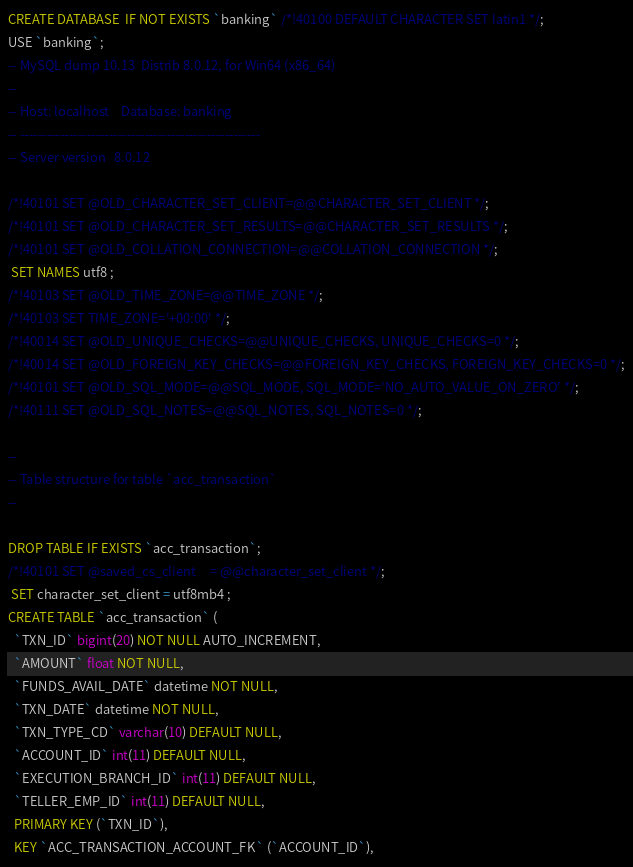Convert code to text. <code><loc_0><loc_0><loc_500><loc_500><_SQL_>CREATE DATABASE  IF NOT EXISTS `banking` /*!40100 DEFAULT CHARACTER SET latin1 */;
USE `banking`;
-- MySQL dump 10.13  Distrib 8.0.12, for Win64 (x86_64)
--
-- Host: localhost    Database: banking
-- ------------------------------------------------------
-- Server version	8.0.12

/*!40101 SET @OLD_CHARACTER_SET_CLIENT=@@CHARACTER_SET_CLIENT */;
/*!40101 SET @OLD_CHARACTER_SET_RESULTS=@@CHARACTER_SET_RESULTS */;
/*!40101 SET @OLD_COLLATION_CONNECTION=@@COLLATION_CONNECTION */;
 SET NAMES utf8 ;
/*!40103 SET @OLD_TIME_ZONE=@@TIME_ZONE */;
/*!40103 SET TIME_ZONE='+00:00' */;
/*!40014 SET @OLD_UNIQUE_CHECKS=@@UNIQUE_CHECKS, UNIQUE_CHECKS=0 */;
/*!40014 SET @OLD_FOREIGN_KEY_CHECKS=@@FOREIGN_KEY_CHECKS, FOREIGN_KEY_CHECKS=0 */;
/*!40101 SET @OLD_SQL_MODE=@@SQL_MODE, SQL_MODE='NO_AUTO_VALUE_ON_ZERO' */;
/*!40111 SET @OLD_SQL_NOTES=@@SQL_NOTES, SQL_NOTES=0 */;

--
-- Table structure for table `acc_transaction`
--

DROP TABLE IF EXISTS `acc_transaction`;
/*!40101 SET @saved_cs_client     = @@character_set_client */;
 SET character_set_client = utf8mb4 ;
CREATE TABLE `acc_transaction` (
  `TXN_ID` bigint(20) NOT NULL AUTO_INCREMENT,
  `AMOUNT` float NOT NULL,
  `FUNDS_AVAIL_DATE` datetime NOT NULL,
  `TXN_DATE` datetime NOT NULL,
  `TXN_TYPE_CD` varchar(10) DEFAULT NULL,
  `ACCOUNT_ID` int(11) DEFAULT NULL,
  `EXECUTION_BRANCH_ID` int(11) DEFAULT NULL,
  `TELLER_EMP_ID` int(11) DEFAULT NULL,
  PRIMARY KEY (`TXN_ID`),
  KEY `ACC_TRANSACTION_ACCOUNT_FK` (`ACCOUNT_ID`),</code> 